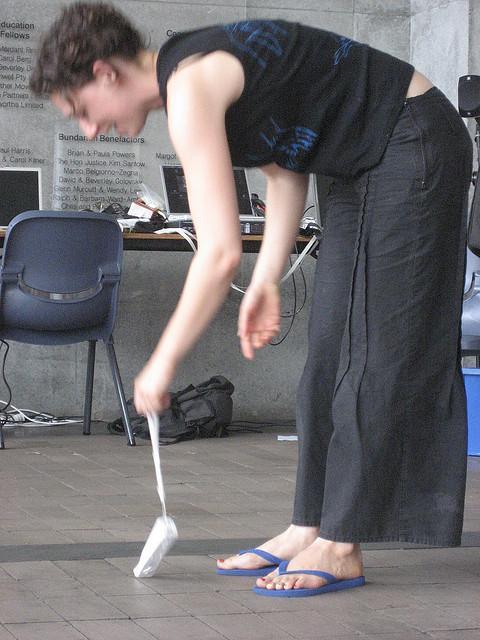How many laptops are there?
Give a very brief answer. 2. 